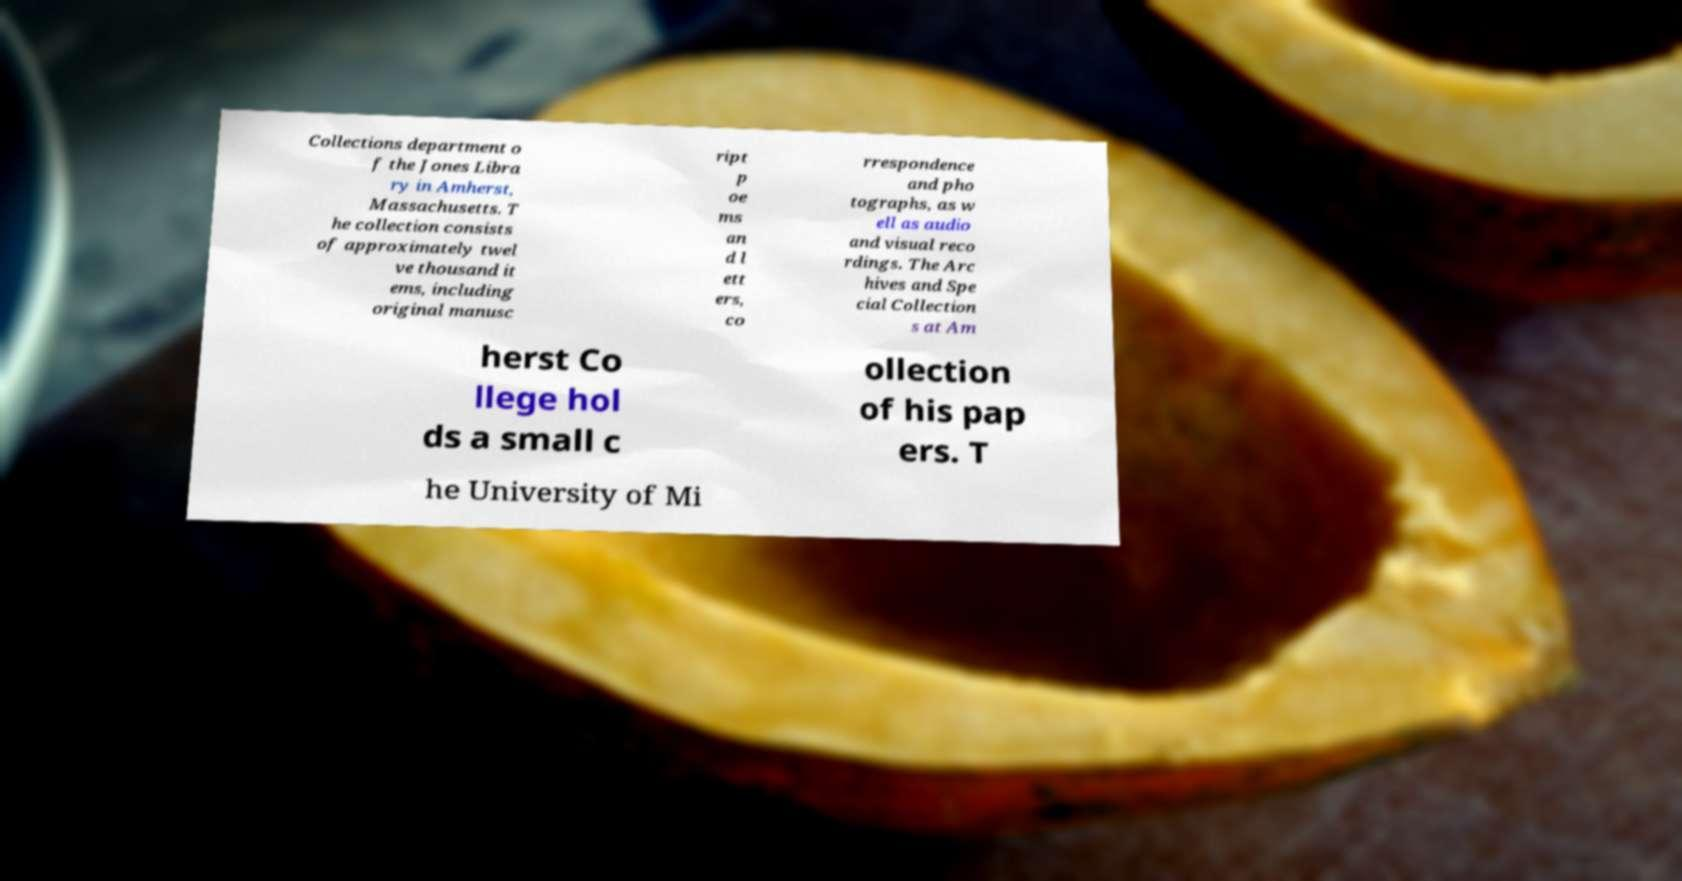Please identify and transcribe the text found in this image. Collections department o f the Jones Libra ry in Amherst, Massachusetts. T he collection consists of approximately twel ve thousand it ems, including original manusc ript p oe ms an d l ett ers, co rrespondence and pho tographs, as w ell as audio and visual reco rdings. The Arc hives and Spe cial Collection s at Am herst Co llege hol ds a small c ollection of his pap ers. T he University of Mi 